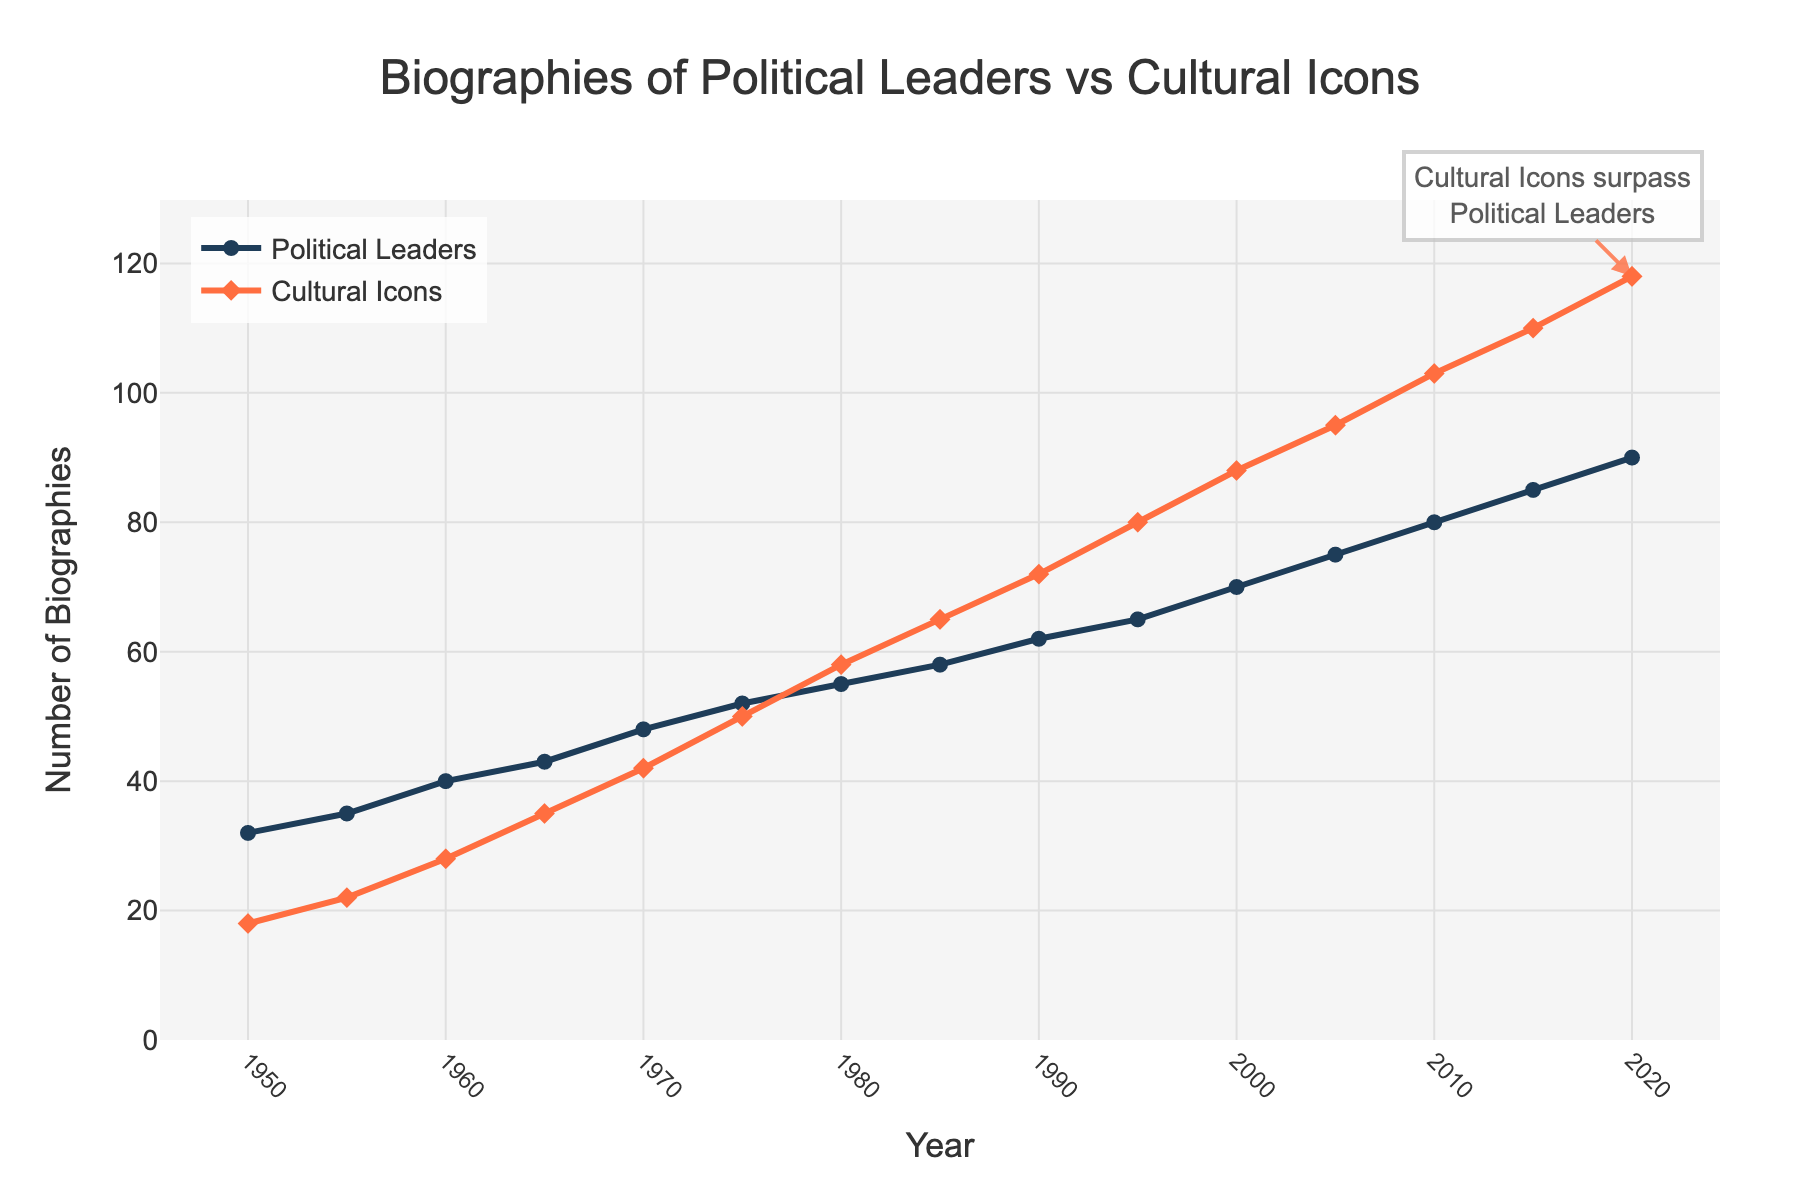What's the overall trend for biographies written about political leaders over the years? The line for political leaders generally slopes upward from 1950 to 2020, indicating an overall increase in the number of biographies written about them. By observing the chart, we can see that the number of biographies consistently rises over the decades.
Answer: Increasing Which year did cultural icons surpass political leaders in the number of biographies written? In the legend, it notes that cultural icons surpass political leaders, and by inspecting the lines, it is clear that this happens in 1980 when the line for cultural icons crosses above the line for political leaders.
Answer: 1980 How does the number of biographies of cultural icons in 2015 compare to that of political leaders in the same year? In 2015, the chart shows 110 biographies for cultural icons compared to 85 for political leaders, so cultural icons have more biographies written about them in that year.
Answer: Cultural icons have more What is the difference in the number of biographies between political leaders and cultural icons in 2020? In 2020, there are 118 biographies for cultural icons and 90 biographies for political leaders. The difference is 118 - 90.
Answer: 28 Which category saw a greater increase in the number of biographies between 1950 and 2000? From 1950 to 2000, cultural icons increased from 18 to 88 biographies, a difference of 70. In the same period, political leaders increased from 32 to 70 biographies, a difference of 38. Cultural icons saw a greater increase.
Answer: Cultural icons What is the slope of the line representing political leaders' biographies from 1950 to 2020? The formula for the slope (m) is (change in y) / (change in x). For political leaders, change in y = 90 - 32, change in x = 2020 - 1950, so the slope is (90 - 32) / (2020 - 1950).
Answer: 0.83 Considering the period from 1960 to 1980, what is the average number of biographies written about cultural icons during these years? The number of biographies in 1960, 1965, 1970, 1975, and 1980 are 28, 35, 42, 50, and 58 respectively. The average is calculated by summing these values and dividing by the number of years: (28 + 35 + 42 + 50 + 58) / 5.
Answer: 42.6 Did the number of biographies for cultural icons ever decrease from one decade to the next in the given period? By inspecting the line for cultural icons from 1950 to 2020, we see that the number of biographies increases or remains constant each decade, with no decreases noted.
Answer: No In which decade was the growth in the number of biographies for political leaders the highest? Inspect each decade: 1950-1960, 1960-1970, 1970-1980, 1980-1990, 1990-2000, 2000-2010, and 2010-2020. Calculate the differences for each: 40-32, 48-40, 55-48, 62-55, 70-62, 75-70, and 80-75. The highest is 8 during 1950-1960.
Answer: 1950-1960 